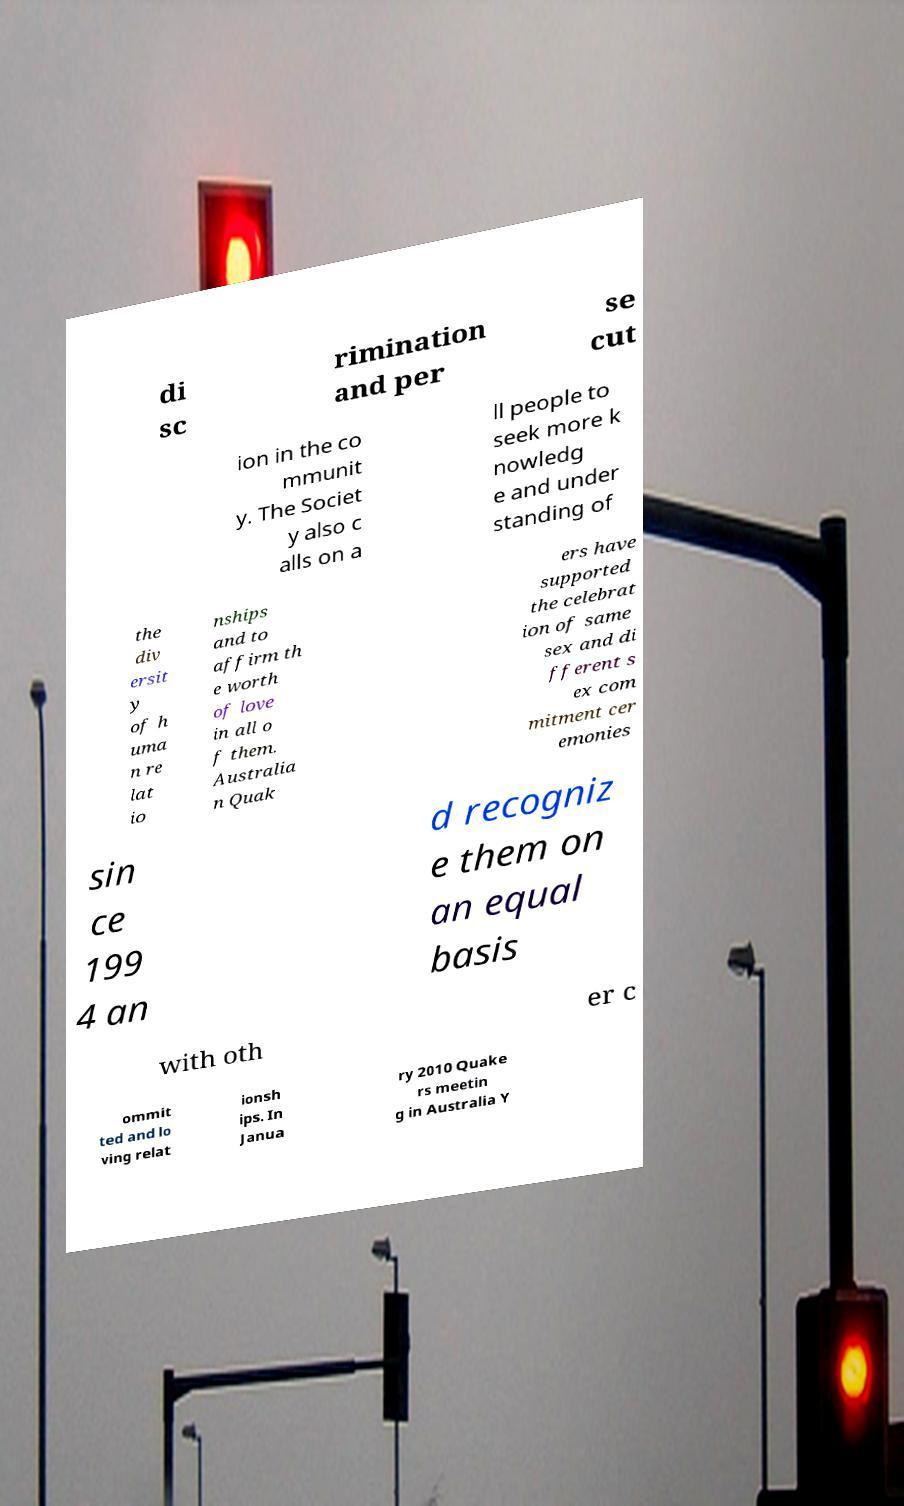Please read and relay the text visible in this image. What does it say? di sc rimination and per se cut ion in the co mmunit y. The Societ y also c alls on a ll people to seek more k nowledg e and under standing of the div ersit y of h uma n re lat io nships and to affirm th e worth of love in all o f them. Australia n Quak ers have supported the celebrat ion of same sex and di fferent s ex com mitment cer emonies sin ce 199 4 an d recogniz e them on an equal basis with oth er c ommit ted and lo ving relat ionsh ips. In Janua ry 2010 Quake rs meetin g in Australia Y 